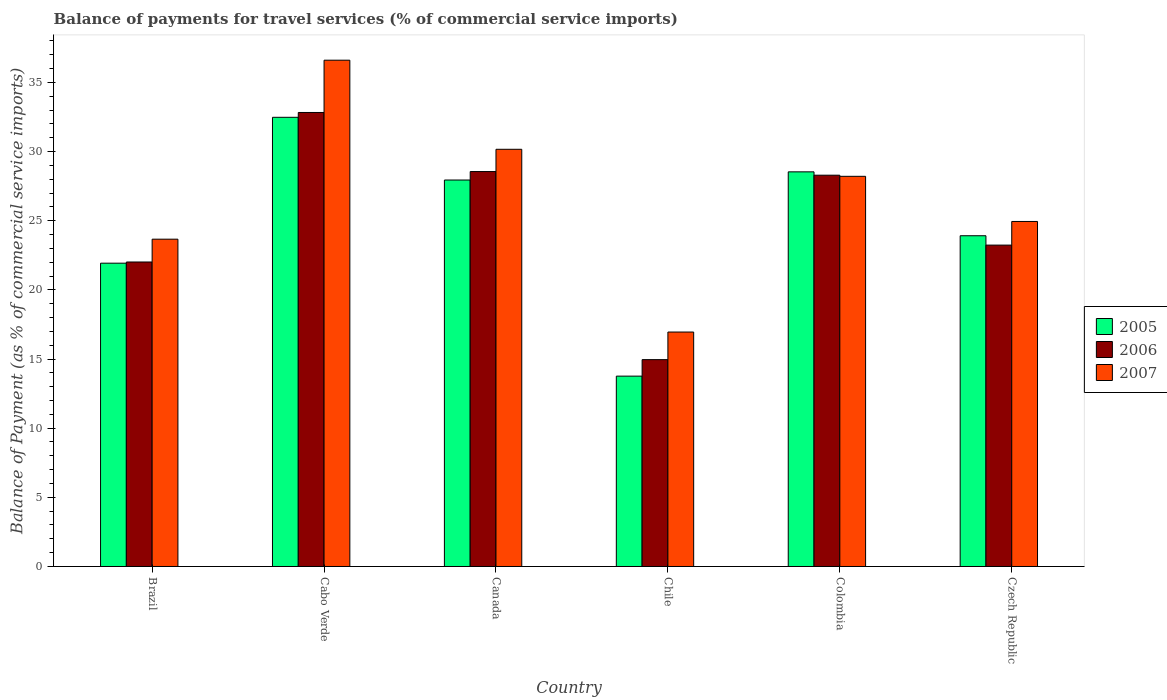How many bars are there on the 3rd tick from the right?
Offer a very short reply. 3. In how many cases, is the number of bars for a given country not equal to the number of legend labels?
Provide a succinct answer. 0. What is the balance of payments for travel services in 2006 in Brazil?
Your answer should be very brief. 22.01. Across all countries, what is the maximum balance of payments for travel services in 2005?
Keep it short and to the point. 32.47. Across all countries, what is the minimum balance of payments for travel services in 2006?
Your answer should be compact. 14.96. In which country was the balance of payments for travel services in 2005 maximum?
Your response must be concise. Cabo Verde. In which country was the balance of payments for travel services in 2005 minimum?
Offer a terse response. Chile. What is the total balance of payments for travel services in 2005 in the graph?
Give a very brief answer. 148.55. What is the difference between the balance of payments for travel services in 2006 in Cabo Verde and that in Canada?
Give a very brief answer. 4.27. What is the difference between the balance of payments for travel services in 2006 in Colombia and the balance of payments for travel services in 2005 in Canada?
Your answer should be very brief. 0.35. What is the average balance of payments for travel services in 2007 per country?
Ensure brevity in your answer.  26.76. What is the difference between the balance of payments for travel services of/in 2005 and balance of payments for travel services of/in 2007 in Brazil?
Offer a terse response. -1.74. In how many countries, is the balance of payments for travel services in 2005 greater than 6 %?
Make the answer very short. 6. What is the ratio of the balance of payments for travel services in 2006 in Chile to that in Czech Republic?
Provide a short and direct response. 0.64. Is the balance of payments for travel services in 2006 in Canada less than that in Czech Republic?
Your answer should be compact. No. What is the difference between the highest and the second highest balance of payments for travel services in 2007?
Provide a short and direct response. 8.4. What is the difference between the highest and the lowest balance of payments for travel services in 2005?
Your answer should be compact. 18.71. In how many countries, is the balance of payments for travel services in 2005 greater than the average balance of payments for travel services in 2005 taken over all countries?
Your answer should be compact. 3. Is the sum of the balance of payments for travel services in 2005 in Canada and Colombia greater than the maximum balance of payments for travel services in 2006 across all countries?
Keep it short and to the point. Yes. How many bars are there?
Give a very brief answer. 18. How many countries are there in the graph?
Provide a short and direct response. 6. What is the difference between two consecutive major ticks on the Y-axis?
Ensure brevity in your answer.  5. Does the graph contain grids?
Your response must be concise. No. Where does the legend appear in the graph?
Give a very brief answer. Center right. How many legend labels are there?
Make the answer very short. 3. How are the legend labels stacked?
Offer a terse response. Vertical. What is the title of the graph?
Provide a succinct answer. Balance of payments for travel services (% of commercial service imports). What is the label or title of the Y-axis?
Your answer should be very brief. Balance of Payment (as % of commercial service imports). What is the Balance of Payment (as % of commercial service imports) of 2005 in Brazil?
Your response must be concise. 21.93. What is the Balance of Payment (as % of commercial service imports) in 2006 in Brazil?
Give a very brief answer. 22.01. What is the Balance of Payment (as % of commercial service imports) in 2007 in Brazil?
Provide a short and direct response. 23.66. What is the Balance of Payment (as % of commercial service imports) of 2005 in Cabo Verde?
Your response must be concise. 32.47. What is the Balance of Payment (as % of commercial service imports) of 2006 in Cabo Verde?
Offer a very short reply. 32.82. What is the Balance of Payment (as % of commercial service imports) of 2007 in Cabo Verde?
Ensure brevity in your answer.  36.6. What is the Balance of Payment (as % of commercial service imports) of 2005 in Canada?
Keep it short and to the point. 27.94. What is the Balance of Payment (as % of commercial service imports) of 2006 in Canada?
Your response must be concise. 28.55. What is the Balance of Payment (as % of commercial service imports) of 2007 in Canada?
Your answer should be compact. 30.16. What is the Balance of Payment (as % of commercial service imports) in 2005 in Chile?
Offer a terse response. 13.76. What is the Balance of Payment (as % of commercial service imports) of 2006 in Chile?
Give a very brief answer. 14.96. What is the Balance of Payment (as % of commercial service imports) in 2007 in Chile?
Give a very brief answer. 16.95. What is the Balance of Payment (as % of commercial service imports) of 2005 in Colombia?
Give a very brief answer. 28.53. What is the Balance of Payment (as % of commercial service imports) in 2006 in Colombia?
Your answer should be very brief. 28.29. What is the Balance of Payment (as % of commercial service imports) in 2007 in Colombia?
Your answer should be very brief. 28.21. What is the Balance of Payment (as % of commercial service imports) in 2005 in Czech Republic?
Offer a terse response. 23.91. What is the Balance of Payment (as % of commercial service imports) in 2006 in Czech Republic?
Give a very brief answer. 23.24. What is the Balance of Payment (as % of commercial service imports) of 2007 in Czech Republic?
Your response must be concise. 24.94. Across all countries, what is the maximum Balance of Payment (as % of commercial service imports) in 2005?
Your answer should be very brief. 32.47. Across all countries, what is the maximum Balance of Payment (as % of commercial service imports) in 2006?
Offer a very short reply. 32.82. Across all countries, what is the maximum Balance of Payment (as % of commercial service imports) of 2007?
Keep it short and to the point. 36.6. Across all countries, what is the minimum Balance of Payment (as % of commercial service imports) in 2005?
Your answer should be very brief. 13.76. Across all countries, what is the minimum Balance of Payment (as % of commercial service imports) of 2006?
Provide a succinct answer. 14.96. Across all countries, what is the minimum Balance of Payment (as % of commercial service imports) in 2007?
Your answer should be compact. 16.95. What is the total Balance of Payment (as % of commercial service imports) in 2005 in the graph?
Your answer should be very brief. 148.55. What is the total Balance of Payment (as % of commercial service imports) of 2006 in the graph?
Provide a succinct answer. 149.87. What is the total Balance of Payment (as % of commercial service imports) in 2007 in the graph?
Ensure brevity in your answer.  160.53. What is the difference between the Balance of Payment (as % of commercial service imports) in 2005 in Brazil and that in Cabo Verde?
Provide a succinct answer. -10.55. What is the difference between the Balance of Payment (as % of commercial service imports) in 2006 in Brazil and that in Cabo Verde?
Your answer should be very brief. -10.81. What is the difference between the Balance of Payment (as % of commercial service imports) of 2007 in Brazil and that in Cabo Verde?
Keep it short and to the point. -12.94. What is the difference between the Balance of Payment (as % of commercial service imports) in 2005 in Brazil and that in Canada?
Give a very brief answer. -6.01. What is the difference between the Balance of Payment (as % of commercial service imports) in 2006 in Brazil and that in Canada?
Keep it short and to the point. -6.54. What is the difference between the Balance of Payment (as % of commercial service imports) of 2007 in Brazil and that in Canada?
Provide a short and direct response. -6.5. What is the difference between the Balance of Payment (as % of commercial service imports) of 2005 in Brazil and that in Chile?
Offer a terse response. 8.17. What is the difference between the Balance of Payment (as % of commercial service imports) of 2006 in Brazil and that in Chile?
Your response must be concise. 7.06. What is the difference between the Balance of Payment (as % of commercial service imports) of 2007 in Brazil and that in Chile?
Ensure brevity in your answer.  6.71. What is the difference between the Balance of Payment (as % of commercial service imports) in 2005 in Brazil and that in Colombia?
Ensure brevity in your answer.  -6.6. What is the difference between the Balance of Payment (as % of commercial service imports) in 2006 in Brazil and that in Colombia?
Give a very brief answer. -6.28. What is the difference between the Balance of Payment (as % of commercial service imports) of 2007 in Brazil and that in Colombia?
Provide a succinct answer. -4.54. What is the difference between the Balance of Payment (as % of commercial service imports) in 2005 in Brazil and that in Czech Republic?
Give a very brief answer. -1.98. What is the difference between the Balance of Payment (as % of commercial service imports) of 2006 in Brazil and that in Czech Republic?
Provide a short and direct response. -1.22. What is the difference between the Balance of Payment (as % of commercial service imports) in 2007 in Brazil and that in Czech Republic?
Provide a succinct answer. -1.28. What is the difference between the Balance of Payment (as % of commercial service imports) of 2005 in Cabo Verde and that in Canada?
Ensure brevity in your answer.  4.53. What is the difference between the Balance of Payment (as % of commercial service imports) in 2006 in Cabo Verde and that in Canada?
Your response must be concise. 4.27. What is the difference between the Balance of Payment (as % of commercial service imports) in 2007 in Cabo Verde and that in Canada?
Give a very brief answer. 6.44. What is the difference between the Balance of Payment (as % of commercial service imports) in 2005 in Cabo Verde and that in Chile?
Provide a short and direct response. 18.71. What is the difference between the Balance of Payment (as % of commercial service imports) of 2006 in Cabo Verde and that in Chile?
Provide a short and direct response. 17.87. What is the difference between the Balance of Payment (as % of commercial service imports) of 2007 in Cabo Verde and that in Chile?
Make the answer very short. 19.65. What is the difference between the Balance of Payment (as % of commercial service imports) of 2005 in Cabo Verde and that in Colombia?
Offer a very short reply. 3.94. What is the difference between the Balance of Payment (as % of commercial service imports) of 2006 in Cabo Verde and that in Colombia?
Keep it short and to the point. 4.53. What is the difference between the Balance of Payment (as % of commercial service imports) of 2007 in Cabo Verde and that in Colombia?
Offer a terse response. 8.4. What is the difference between the Balance of Payment (as % of commercial service imports) of 2005 in Cabo Verde and that in Czech Republic?
Your response must be concise. 8.56. What is the difference between the Balance of Payment (as % of commercial service imports) in 2006 in Cabo Verde and that in Czech Republic?
Offer a very short reply. 9.59. What is the difference between the Balance of Payment (as % of commercial service imports) in 2007 in Cabo Verde and that in Czech Republic?
Your answer should be compact. 11.66. What is the difference between the Balance of Payment (as % of commercial service imports) of 2005 in Canada and that in Chile?
Provide a short and direct response. 14.18. What is the difference between the Balance of Payment (as % of commercial service imports) of 2006 in Canada and that in Chile?
Provide a succinct answer. 13.6. What is the difference between the Balance of Payment (as % of commercial service imports) of 2007 in Canada and that in Chile?
Your answer should be very brief. 13.21. What is the difference between the Balance of Payment (as % of commercial service imports) in 2005 in Canada and that in Colombia?
Provide a succinct answer. -0.59. What is the difference between the Balance of Payment (as % of commercial service imports) in 2006 in Canada and that in Colombia?
Offer a terse response. 0.26. What is the difference between the Balance of Payment (as % of commercial service imports) in 2007 in Canada and that in Colombia?
Your answer should be compact. 1.95. What is the difference between the Balance of Payment (as % of commercial service imports) in 2005 in Canada and that in Czech Republic?
Your answer should be very brief. 4.03. What is the difference between the Balance of Payment (as % of commercial service imports) in 2006 in Canada and that in Czech Republic?
Keep it short and to the point. 5.32. What is the difference between the Balance of Payment (as % of commercial service imports) in 2007 in Canada and that in Czech Republic?
Make the answer very short. 5.22. What is the difference between the Balance of Payment (as % of commercial service imports) in 2005 in Chile and that in Colombia?
Offer a very short reply. -14.77. What is the difference between the Balance of Payment (as % of commercial service imports) in 2006 in Chile and that in Colombia?
Your answer should be compact. -13.33. What is the difference between the Balance of Payment (as % of commercial service imports) of 2007 in Chile and that in Colombia?
Keep it short and to the point. -11.26. What is the difference between the Balance of Payment (as % of commercial service imports) in 2005 in Chile and that in Czech Republic?
Provide a succinct answer. -10.15. What is the difference between the Balance of Payment (as % of commercial service imports) of 2006 in Chile and that in Czech Republic?
Keep it short and to the point. -8.28. What is the difference between the Balance of Payment (as % of commercial service imports) in 2007 in Chile and that in Czech Republic?
Offer a very short reply. -7.99. What is the difference between the Balance of Payment (as % of commercial service imports) of 2005 in Colombia and that in Czech Republic?
Provide a succinct answer. 4.62. What is the difference between the Balance of Payment (as % of commercial service imports) of 2006 in Colombia and that in Czech Republic?
Give a very brief answer. 5.05. What is the difference between the Balance of Payment (as % of commercial service imports) in 2007 in Colombia and that in Czech Republic?
Keep it short and to the point. 3.26. What is the difference between the Balance of Payment (as % of commercial service imports) of 2005 in Brazil and the Balance of Payment (as % of commercial service imports) of 2006 in Cabo Verde?
Your answer should be very brief. -10.89. What is the difference between the Balance of Payment (as % of commercial service imports) in 2005 in Brazil and the Balance of Payment (as % of commercial service imports) in 2007 in Cabo Verde?
Give a very brief answer. -14.68. What is the difference between the Balance of Payment (as % of commercial service imports) in 2006 in Brazil and the Balance of Payment (as % of commercial service imports) in 2007 in Cabo Verde?
Your answer should be very brief. -14.59. What is the difference between the Balance of Payment (as % of commercial service imports) in 2005 in Brazil and the Balance of Payment (as % of commercial service imports) in 2006 in Canada?
Keep it short and to the point. -6.62. What is the difference between the Balance of Payment (as % of commercial service imports) in 2005 in Brazil and the Balance of Payment (as % of commercial service imports) in 2007 in Canada?
Provide a succinct answer. -8.23. What is the difference between the Balance of Payment (as % of commercial service imports) in 2006 in Brazil and the Balance of Payment (as % of commercial service imports) in 2007 in Canada?
Make the answer very short. -8.15. What is the difference between the Balance of Payment (as % of commercial service imports) of 2005 in Brazil and the Balance of Payment (as % of commercial service imports) of 2006 in Chile?
Your response must be concise. 6.97. What is the difference between the Balance of Payment (as % of commercial service imports) in 2005 in Brazil and the Balance of Payment (as % of commercial service imports) in 2007 in Chile?
Your response must be concise. 4.98. What is the difference between the Balance of Payment (as % of commercial service imports) in 2006 in Brazil and the Balance of Payment (as % of commercial service imports) in 2007 in Chile?
Offer a terse response. 5.06. What is the difference between the Balance of Payment (as % of commercial service imports) in 2005 in Brazil and the Balance of Payment (as % of commercial service imports) in 2006 in Colombia?
Ensure brevity in your answer.  -6.36. What is the difference between the Balance of Payment (as % of commercial service imports) in 2005 in Brazil and the Balance of Payment (as % of commercial service imports) in 2007 in Colombia?
Your answer should be very brief. -6.28. What is the difference between the Balance of Payment (as % of commercial service imports) in 2006 in Brazil and the Balance of Payment (as % of commercial service imports) in 2007 in Colombia?
Offer a very short reply. -6.19. What is the difference between the Balance of Payment (as % of commercial service imports) in 2005 in Brazil and the Balance of Payment (as % of commercial service imports) in 2006 in Czech Republic?
Provide a short and direct response. -1.31. What is the difference between the Balance of Payment (as % of commercial service imports) of 2005 in Brazil and the Balance of Payment (as % of commercial service imports) of 2007 in Czech Republic?
Provide a succinct answer. -3.02. What is the difference between the Balance of Payment (as % of commercial service imports) in 2006 in Brazil and the Balance of Payment (as % of commercial service imports) in 2007 in Czech Republic?
Your response must be concise. -2.93. What is the difference between the Balance of Payment (as % of commercial service imports) of 2005 in Cabo Verde and the Balance of Payment (as % of commercial service imports) of 2006 in Canada?
Your response must be concise. 3.92. What is the difference between the Balance of Payment (as % of commercial service imports) of 2005 in Cabo Verde and the Balance of Payment (as % of commercial service imports) of 2007 in Canada?
Offer a terse response. 2.31. What is the difference between the Balance of Payment (as % of commercial service imports) of 2006 in Cabo Verde and the Balance of Payment (as % of commercial service imports) of 2007 in Canada?
Ensure brevity in your answer.  2.66. What is the difference between the Balance of Payment (as % of commercial service imports) of 2005 in Cabo Verde and the Balance of Payment (as % of commercial service imports) of 2006 in Chile?
Keep it short and to the point. 17.52. What is the difference between the Balance of Payment (as % of commercial service imports) in 2005 in Cabo Verde and the Balance of Payment (as % of commercial service imports) in 2007 in Chile?
Your answer should be very brief. 15.52. What is the difference between the Balance of Payment (as % of commercial service imports) of 2006 in Cabo Verde and the Balance of Payment (as % of commercial service imports) of 2007 in Chile?
Provide a succinct answer. 15.87. What is the difference between the Balance of Payment (as % of commercial service imports) of 2005 in Cabo Verde and the Balance of Payment (as % of commercial service imports) of 2006 in Colombia?
Provide a succinct answer. 4.19. What is the difference between the Balance of Payment (as % of commercial service imports) in 2005 in Cabo Verde and the Balance of Payment (as % of commercial service imports) in 2007 in Colombia?
Ensure brevity in your answer.  4.27. What is the difference between the Balance of Payment (as % of commercial service imports) of 2006 in Cabo Verde and the Balance of Payment (as % of commercial service imports) of 2007 in Colombia?
Your response must be concise. 4.62. What is the difference between the Balance of Payment (as % of commercial service imports) in 2005 in Cabo Verde and the Balance of Payment (as % of commercial service imports) in 2006 in Czech Republic?
Ensure brevity in your answer.  9.24. What is the difference between the Balance of Payment (as % of commercial service imports) in 2005 in Cabo Verde and the Balance of Payment (as % of commercial service imports) in 2007 in Czech Republic?
Provide a succinct answer. 7.53. What is the difference between the Balance of Payment (as % of commercial service imports) in 2006 in Cabo Verde and the Balance of Payment (as % of commercial service imports) in 2007 in Czech Republic?
Your answer should be very brief. 7.88. What is the difference between the Balance of Payment (as % of commercial service imports) of 2005 in Canada and the Balance of Payment (as % of commercial service imports) of 2006 in Chile?
Ensure brevity in your answer.  12.99. What is the difference between the Balance of Payment (as % of commercial service imports) in 2005 in Canada and the Balance of Payment (as % of commercial service imports) in 2007 in Chile?
Offer a very short reply. 10.99. What is the difference between the Balance of Payment (as % of commercial service imports) of 2006 in Canada and the Balance of Payment (as % of commercial service imports) of 2007 in Chile?
Your answer should be compact. 11.6. What is the difference between the Balance of Payment (as % of commercial service imports) in 2005 in Canada and the Balance of Payment (as % of commercial service imports) in 2006 in Colombia?
Give a very brief answer. -0.35. What is the difference between the Balance of Payment (as % of commercial service imports) of 2005 in Canada and the Balance of Payment (as % of commercial service imports) of 2007 in Colombia?
Provide a succinct answer. -0.27. What is the difference between the Balance of Payment (as % of commercial service imports) of 2006 in Canada and the Balance of Payment (as % of commercial service imports) of 2007 in Colombia?
Your answer should be compact. 0.34. What is the difference between the Balance of Payment (as % of commercial service imports) of 2005 in Canada and the Balance of Payment (as % of commercial service imports) of 2006 in Czech Republic?
Make the answer very short. 4.71. What is the difference between the Balance of Payment (as % of commercial service imports) of 2005 in Canada and the Balance of Payment (as % of commercial service imports) of 2007 in Czech Republic?
Ensure brevity in your answer.  3. What is the difference between the Balance of Payment (as % of commercial service imports) of 2006 in Canada and the Balance of Payment (as % of commercial service imports) of 2007 in Czech Republic?
Offer a terse response. 3.61. What is the difference between the Balance of Payment (as % of commercial service imports) in 2005 in Chile and the Balance of Payment (as % of commercial service imports) in 2006 in Colombia?
Give a very brief answer. -14.53. What is the difference between the Balance of Payment (as % of commercial service imports) in 2005 in Chile and the Balance of Payment (as % of commercial service imports) in 2007 in Colombia?
Your answer should be very brief. -14.45. What is the difference between the Balance of Payment (as % of commercial service imports) in 2006 in Chile and the Balance of Payment (as % of commercial service imports) in 2007 in Colombia?
Ensure brevity in your answer.  -13.25. What is the difference between the Balance of Payment (as % of commercial service imports) of 2005 in Chile and the Balance of Payment (as % of commercial service imports) of 2006 in Czech Republic?
Your answer should be very brief. -9.47. What is the difference between the Balance of Payment (as % of commercial service imports) in 2005 in Chile and the Balance of Payment (as % of commercial service imports) in 2007 in Czech Republic?
Your answer should be compact. -11.18. What is the difference between the Balance of Payment (as % of commercial service imports) in 2006 in Chile and the Balance of Payment (as % of commercial service imports) in 2007 in Czech Republic?
Keep it short and to the point. -9.99. What is the difference between the Balance of Payment (as % of commercial service imports) in 2005 in Colombia and the Balance of Payment (as % of commercial service imports) in 2006 in Czech Republic?
Keep it short and to the point. 5.3. What is the difference between the Balance of Payment (as % of commercial service imports) in 2005 in Colombia and the Balance of Payment (as % of commercial service imports) in 2007 in Czech Republic?
Provide a succinct answer. 3.59. What is the difference between the Balance of Payment (as % of commercial service imports) of 2006 in Colombia and the Balance of Payment (as % of commercial service imports) of 2007 in Czech Republic?
Your answer should be very brief. 3.34. What is the average Balance of Payment (as % of commercial service imports) in 2005 per country?
Your answer should be compact. 24.76. What is the average Balance of Payment (as % of commercial service imports) in 2006 per country?
Ensure brevity in your answer.  24.98. What is the average Balance of Payment (as % of commercial service imports) in 2007 per country?
Keep it short and to the point. 26.76. What is the difference between the Balance of Payment (as % of commercial service imports) in 2005 and Balance of Payment (as % of commercial service imports) in 2006 in Brazil?
Your response must be concise. -0.09. What is the difference between the Balance of Payment (as % of commercial service imports) of 2005 and Balance of Payment (as % of commercial service imports) of 2007 in Brazil?
Keep it short and to the point. -1.74. What is the difference between the Balance of Payment (as % of commercial service imports) of 2006 and Balance of Payment (as % of commercial service imports) of 2007 in Brazil?
Keep it short and to the point. -1.65. What is the difference between the Balance of Payment (as % of commercial service imports) of 2005 and Balance of Payment (as % of commercial service imports) of 2006 in Cabo Verde?
Keep it short and to the point. -0.35. What is the difference between the Balance of Payment (as % of commercial service imports) in 2005 and Balance of Payment (as % of commercial service imports) in 2007 in Cabo Verde?
Give a very brief answer. -4.13. What is the difference between the Balance of Payment (as % of commercial service imports) of 2006 and Balance of Payment (as % of commercial service imports) of 2007 in Cabo Verde?
Make the answer very short. -3.78. What is the difference between the Balance of Payment (as % of commercial service imports) in 2005 and Balance of Payment (as % of commercial service imports) in 2006 in Canada?
Make the answer very short. -0.61. What is the difference between the Balance of Payment (as % of commercial service imports) in 2005 and Balance of Payment (as % of commercial service imports) in 2007 in Canada?
Make the answer very short. -2.22. What is the difference between the Balance of Payment (as % of commercial service imports) in 2006 and Balance of Payment (as % of commercial service imports) in 2007 in Canada?
Offer a very short reply. -1.61. What is the difference between the Balance of Payment (as % of commercial service imports) in 2005 and Balance of Payment (as % of commercial service imports) in 2006 in Chile?
Ensure brevity in your answer.  -1.19. What is the difference between the Balance of Payment (as % of commercial service imports) in 2005 and Balance of Payment (as % of commercial service imports) in 2007 in Chile?
Keep it short and to the point. -3.19. What is the difference between the Balance of Payment (as % of commercial service imports) in 2006 and Balance of Payment (as % of commercial service imports) in 2007 in Chile?
Give a very brief answer. -1.99. What is the difference between the Balance of Payment (as % of commercial service imports) in 2005 and Balance of Payment (as % of commercial service imports) in 2006 in Colombia?
Your response must be concise. 0.24. What is the difference between the Balance of Payment (as % of commercial service imports) of 2005 and Balance of Payment (as % of commercial service imports) of 2007 in Colombia?
Keep it short and to the point. 0.32. What is the difference between the Balance of Payment (as % of commercial service imports) in 2006 and Balance of Payment (as % of commercial service imports) in 2007 in Colombia?
Your answer should be compact. 0.08. What is the difference between the Balance of Payment (as % of commercial service imports) of 2005 and Balance of Payment (as % of commercial service imports) of 2006 in Czech Republic?
Provide a short and direct response. 0.68. What is the difference between the Balance of Payment (as % of commercial service imports) in 2005 and Balance of Payment (as % of commercial service imports) in 2007 in Czech Republic?
Keep it short and to the point. -1.03. What is the difference between the Balance of Payment (as % of commercial service imports) in 2006 and Balance of Payment (as % of commercial service imports) in 2007 in Czech Republic?
Keep it short and to the point. -1.71. What is the ratio of the Balance of Payment (as % of commercial service imports) in 2005 in Brazil to that in Cabo Verde?
Ensure brevity in your answer.  0.68. What is the ratio of the Balance of Payment (as % of commercial service imports) in 2006 in Brazil to that in Cabo Verde?
Keep it short and to the point. 0.67. What is the ratio of the Balance of Payment (as % of commercial service imports) in 2007 in Brazil to that in Cabo Verde?
Your answer should be very brief. 0.65. What is the ratio of the Balance of Payment (as % of commercial service imports) in 2005 in Brazil to that in Canada?
Ensure brevity in your answer.  0.78. What is the ratio of the Balance of Payment (as % of commercial service imports) in 2006 in Brazil to that in Canada?
Your answer should be very brief. 0.77. What is the ratio of the Balance of Payment (as % of commercial service imports) in 2007 in Brazil to that in Canada?
Your answer should be compact. 0.78. What is the ratio of the Balance of Payment (as % of commercial service imports) in 2005 in Brazil to that in Chile?
Your answer should be very brief. 1.59. What is the ratio of the Balance of Payment (as % of commercial service imports) of 2006 in Brazil to that in Chile?
Your answer should be compact. 1.47. What is the ratio of the Balance of Payment (as % of commercial service imports) in 2007 in Brazil to that in Chile?
Make the answer very short. 1.4. What is the ratio of the Balance of Payment (as % of commercial service imports) in 2005 in Brazil to that in Colombia?
Provide a short and direct response. 0.77. What is the ratio of the Balance of Payment (as % of commercial service imports) of 2006 in Brazil to that in Colombia?
Make the answer very short. 0.78. What is the ratio of the Balance of Payment (as % of commercial service imports) of 2007 in Brazil to that in Colombia?
Ensure brevity in your answer.  0.84. What is the ratio of the Balance of Payment (as % of commercial service imports) of 2005 in Brazil to that in Czech Republic?
Make the answer very short. 0.92. What is the ratio of the Balance of Payment (as % of commercial service imports) in 2006 in Brazil to that in Czech Republic?
Make the answer very short. 0.95. What is the ratio of the Balance of Payment (as % of commercial service imports) in 2007 in Brazil to that in Czech Republic?
Offer a very short reply. 0.95. What is the ratio of the Balance of Payment (as % of commercial service imports) of 2005 in Cabo Verde to that in Canada?
Provide a short and direct response. 1.16. What is the ratio of the Balance of Payment (as % of commercial service imports) of 2006 in Cabo Verde to that in Canada?
Offer a very short reply. 1.15. What is the ratio of the Balance of Payment (as % of commercial service imports) in 2007 in Cabo Verde to that in Canada?
Keep it short and to the point. 1.21. What is the ratio of the Balance of Payment (as % of commercial service imports) of 2005 in Cabo Verde to that in Chile?
Provide a succinct answer. 2.36. What is the ratio of the Balance of Payment (as % of commercial service imports) of 2006 in Cabo Verde to that in Chile?
Provide a short and direct response. 2.19. What is the ratio of the Balance of Payment (as % of commercial service imports) of 2007 in Cabo Verde to that in Chile?
Your answer should be compact. 2.16. What is the ratio of the Balance of Payment (as % of commercial service imports) in 2005 in Cabo Verde to that in Colombia?
Your response must be concise. 1.14. What is the ratio of the Balance of Payment (as % of commercial service imports) in 2006 in Cabo Verde to that in Colombia?
Provide a short and direct response. 1.16. What is the ratio of the Balance of Payment (as % of commercial service imports) in 2007 in Cabo Verde to that in Colombia?
Your answer should be compact. 1.3. What is the ratio of the Balance of Payment (as % of commercial service imports) in 2005 in Cabo Verde to that in Czech Republic?
Ensure brevity in your answer.  1.36. What is the ratio of the Balance of Payment (as % of commercial service imports) of 2006 in Cabo Verde to that in Czech Republic?
Provide a short and direct response. 1.41. What is the ratio of the Balance of Payment (as % of commercial service imports) in 2007 in Cabo Verde to that in Czech Republic?
Offer a terse response. 1.47. What is the ratio of the Balance of Payment (as % of commercial service imports) in 2005 in Canada to that in Chile?
Provide a short and direct response. 2.03. What is the ratio of the Balance of Payment (as % of commercial service imports) in 2006 in Canada to that in Chile?
Provide a short and direct response. 1.91. What is the ratio of the Balance of Payment (as % of commercial service imports) of 2007 in Canada to that in Chile?
Ensure brevity in your answer.  1.78. What is the ratio of the Balance of Payment (as % of commercial service imports) of 2005 in Canada to that in Colombia?
Provide a short and direct response. 0.98. What is the ratio of the Balance of Payment (as % of commercial service imports) in 2006 in Canada to that in Colombia?
Your answer should be very brief. 1.01. What is the ratio of the Balance of Payment (as % of commercial service imports) in 2007 in Canada to that in Colombia?
Provide a short and direct response. 1.07. What is the ratio of the Balance of Payment (as % of commercial service imports) of 2005 in Canada to that in Czech Republic?
Make the answer very short. 1.17. What is the ratio of the Balance of Payment (as % of commercial service imports) in 2006 in Canada to that in Czech Republic?
Offer a terse response. 1.23. What is the ratio of the Balance of Payment (as % of commercial service imports) of 2007 in Canada to that in Czech Republic?
Give a very brief answer. 1.21. What is the ratio of the Balance of Payment (as % of commercial service imports) of 2005 in Chile to that in Colombia?
Offer a terse response. 0.48. What is the ratio of the Balance of Payment (as % of commercial service imports) in 2006 in Chile to that in Colombia?
Give a very brief answer. 0.53. What is the ratio of the Balance of Payment (as % of commercial service imports) in 2007 in Chile to that in Colombia?
Your answer should be very brief. 0.6. What is the ratio of the Balance of Payment (as % of commercial service imports) of 2005 in Chile to that in Czech Republic?
Make the answer very short. 0.58. What is the ratio of the Balance of Payment (as % of commercial service imports) in 2006 in Chile to that in Czech Republic?
Offer a terse response. 0.64. What is the ratio of the Balance of Payment (as % of commercial service imports) of 2007 in Chile to that in Czech Republic?
Provide a short and direct response. 0.68. What is the ratio of the Balance of Payment (as % of commercial service imports) in 2005 in Colombia to that in Czech Republic?
Ensure brevity in your answer.  1.19. What is the ratio of the Balance of Payment (as % of commercial service imports) of 2006 in Colombia to that in Czech Republic?
Ensure brevity in your answer.  1.22. What is the ratio of the Balance of Payment (as % of commercial service imports) in 2007 in Colombia to that in Czech Republic?
Your response must be concise. 1.13. What is the difference between the highest and the second highest Balance of Payment (as % of commercial service imports) in 2005?
Offer a very short reply. 3.94. What is the difference between the highest and the second highest Balance of Payment (as % of commercial service imports) in 2006?
Your response must be concise. 4.27. What is the difference between the highest and the second highest Balance of Payment (as % of commercial service imports) of 2007?
Ensure brevity in your answer.  6.44. What is the difference between the highest and the lowest Balance of Payment (as % of commercial service imports) of 2005?
Offer a very short reply. 18.71. What is the difference between the highest and the lowest Balance of Payment (as % of commercial service imports) in 2006?
Ensure brevity in your answer.  17.87. What is the difference between the highest and the lowest Balance of Payment (as % of commercial service imports) of 2007?
Your answer should be very brief. 19.65. 